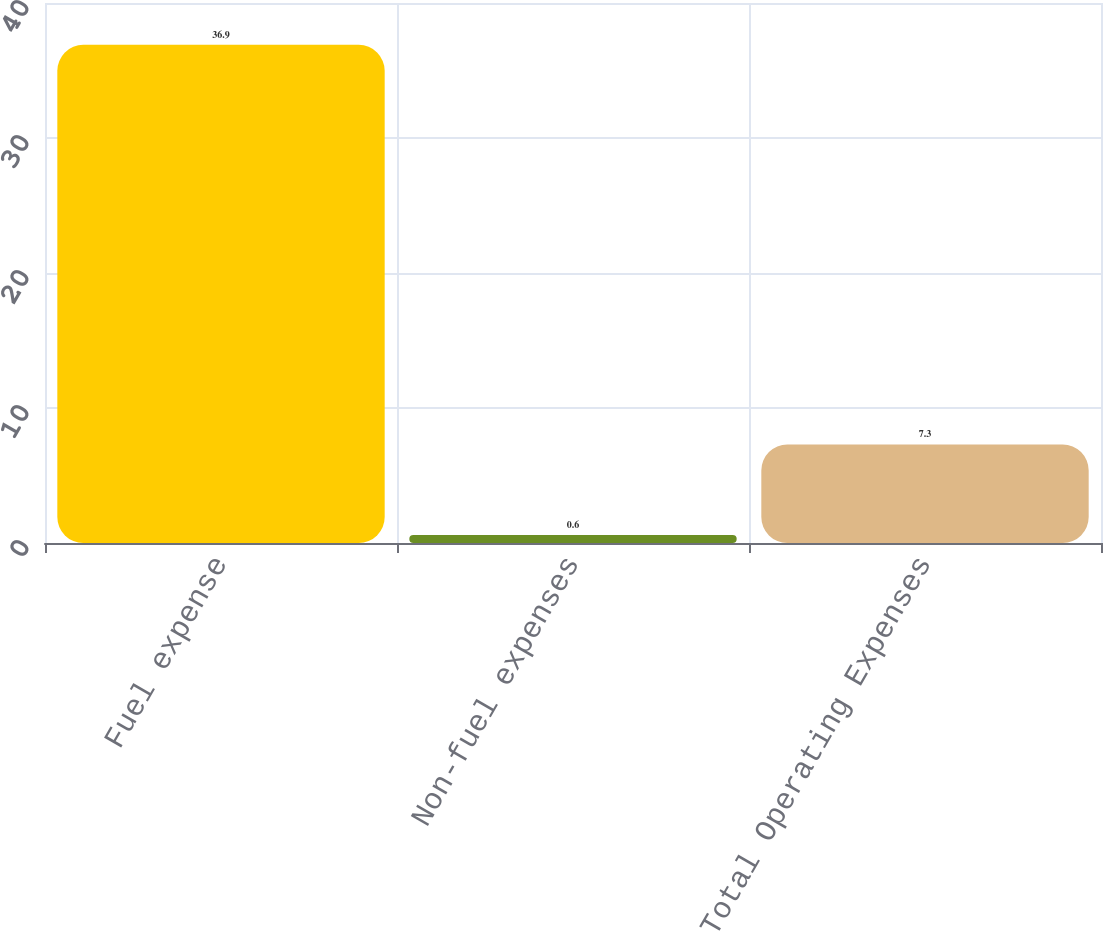Convert chart to OTSL. <chart><loc_0><loc_0><loc_500><loc_500><bar_chart><fcel>Fuel expense<fcel>Non-fuel expenses<fcel>Total Operating Expenses<nl><fcel>36.9<fcel>0.6<fcel>7.3<nl></chart> 